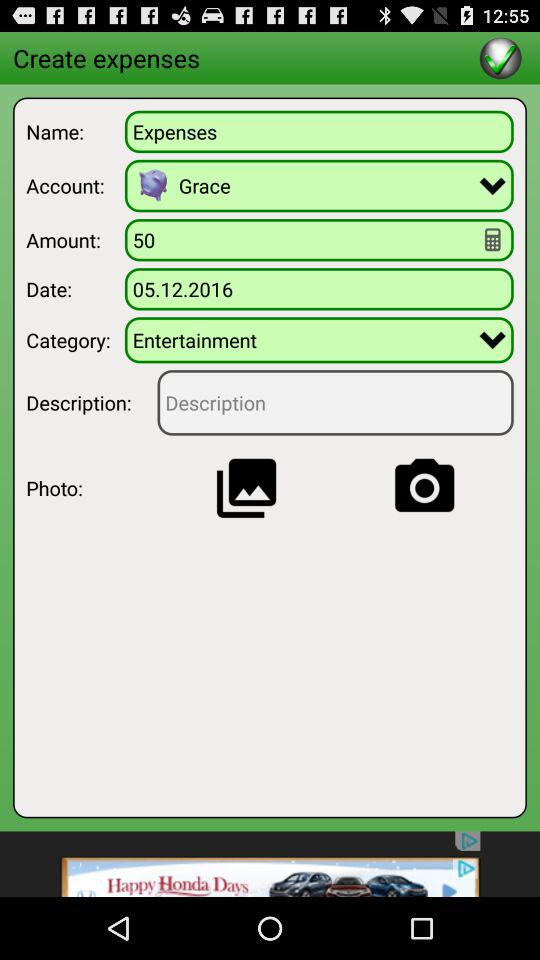Which account is selected? The selected account is Grace. 